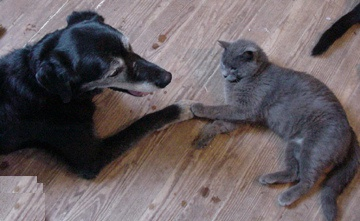Describe the objects in this image and their specific colors. I can see dog in gray, black, and blue tones and cat in gray and black tones in this image. 